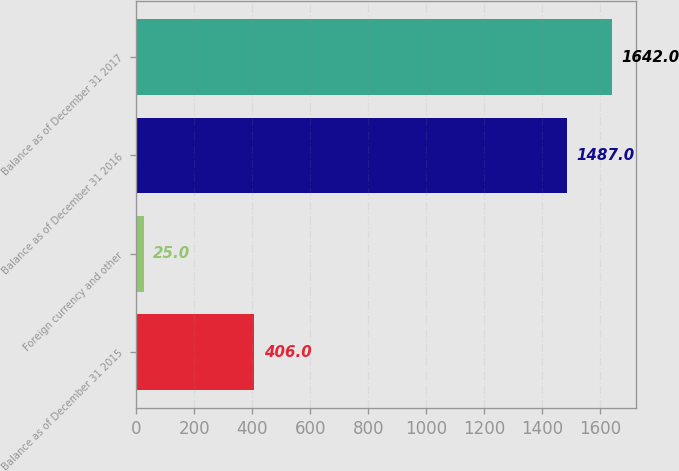<chart> <loc_0><loc_0><loc_500><loc_500><bar_chart><fcel>Balance as of December 31 2015<fcel>Foreign currency and other<fcel>Balance as of December 31 2016<fcel>Balance as of December 31 2017<nl><fcel>406<fcel>25<fcel>1487<fcel>1642<nl></chart> 